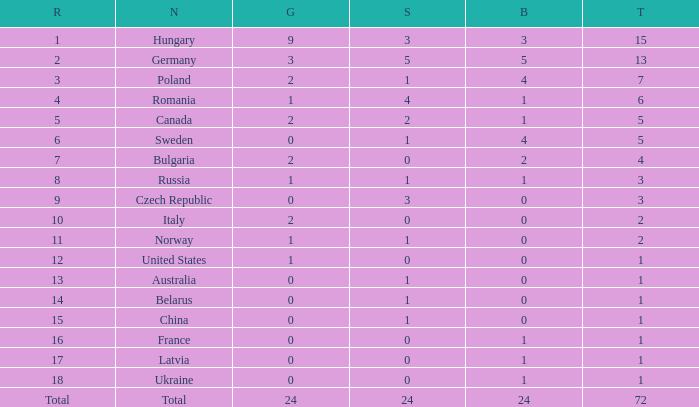What average total has 0 as the gold, with 6 as the rank? 5.0. 